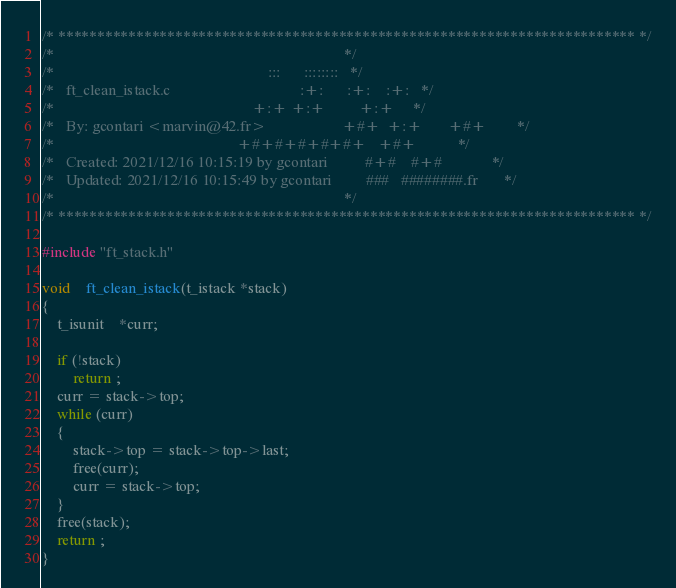<code> <loc_0><loc_0><loc_500><loc_500><_C_>/* ************************************************************************** */
/*                                                                            */
/*                                                        :::      ::::::::   */
/*   ft_clean_istack.c                                  :+:      :+:    :+:   */
/*                                                    +:+ +:+         +:+     */
/*   By: gcontari <marvin@42.fr>                    +#+  +:+       +#+        */
/*                                                +#+#+#+#+#+   +#+           */
/*   Created: 2021/12/16 10:15:19 by gcontari          #+#    #+#             */
/*   Updated: 2021/12/16 10:15:49 by gcontari         ###   ########.fr       */
/*                                                                            */
/* ************************************************************************** */

#include "ft_stack.h"

void	ft_clean_istack(t_istack *stack)
{
	t_isunit	*curr;

	if (!stack)
		return ;
	curr = stack->top;
	while (curr)
	{
		stack->top = stack->top->last;
		free(curr);
		curr = stack->top;
	}
	free(stack);
	return ;
}
</code> 